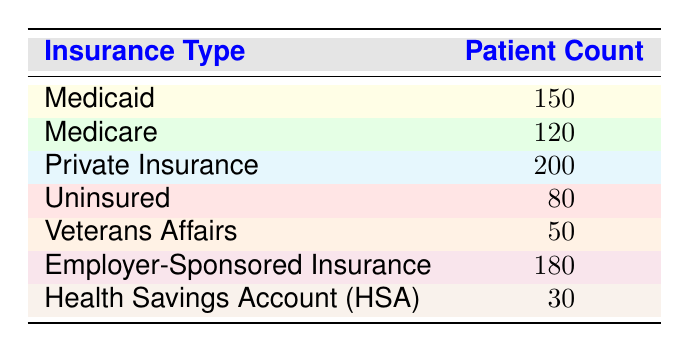What is the patient count for Medicare? The patient count for Medicare is directly provided in the table. By referring to the row labeled "Medicare," we find the patient count listed as 120.
Answer: 120 Which insurance type has the highest patient count? To determine which insurance type has the highest patient count, we compare the patient counts listed in each row. The highest number is found in the row for "Private Insurance," which has a count of 200.
Answer: Private Insurance What is the total patient count for all insurance types? To find the total patient count, we add the patient counts from all insurance types together: 150 (Medicaid) + 120 (Medicare) + 200 (Private Insurance) + 80 (Uninsured) + 50 (Veterans Affairs) + 180 (Employer-Sponsored Insurance) + 30 (HSA) = 810.
Answer: 810 Is the number of patients with Employer-Sponsored Insurance greater than those with Medicaid? Comparing the patient counts from the respective rows, Employer-Sponsored Insurance has a count of 180, while Medicaid has 150. Since 180 is greater than 150, the statement is true.
Answer: Yes What is the average number of patients per insurance type for the types listed? The average is calculated by taking the total number of patients and dividing it by the number of insurance types. There are 7 types of insurance, and we've calculated the total patient count as 810. So, 810 divided by 7 equals roughly 115.71, which we can round to 116.
Answer: 116 Which insurance type has the least number of patients, and what is that number? To find the insurance type with the least patients, we look through the patient counts in the table. The row for "Health Savings Account (HSA)" shows the least with a count of 30.
Answer: Health Savings Account (HSA), 30 How many more patients are covered by Private Insurance than by Uninsured? The count for Private Insurance is 200, and for Uninsured, it is 80. To find how many more patients are covered by Private Insurance, we subtract the Uninsured count from the Private Insurance count: 200 - 80 = 120.
Answer: 120 Is the total number of uninsured patients less than the total number of those with Medicare? The table shows 80 uninsured patients and 120 Medicare patients. Since 80 is less than 120, the statement is true.
Answer: Yes 